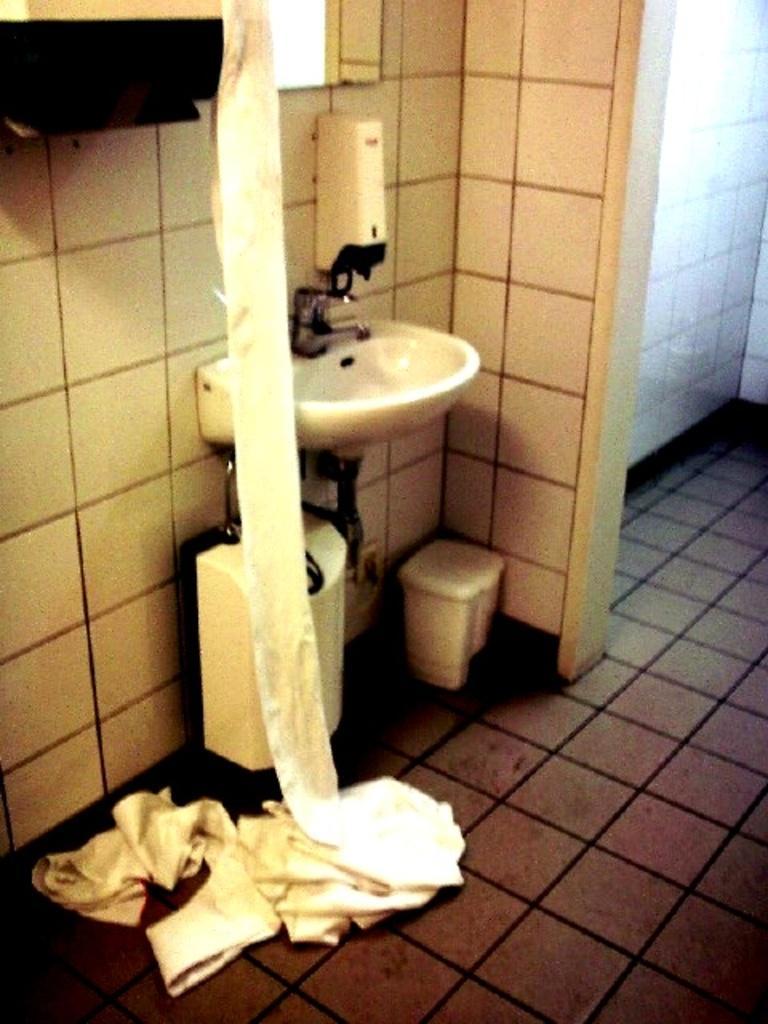Describe this image in one or two sentences. In this image I can see the sink and the tap. To the side I can see the soap dispenser to the wall. In the top I can see the mirror. To the side of the sink I can see the dustbin and the tissues can be seen. 